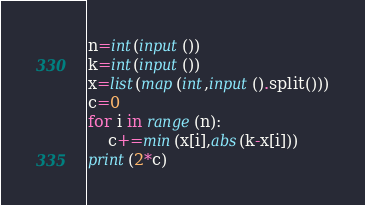<code> <loc_0><loc_0><loc_500><loc_500><_Python_>n=int(input())
k=int(input())
x=list(map(int,input().split()))
c=0
for i in range(n):
    c+=min(x[i],abs(k-x[i]))
print(2*c)</code> 